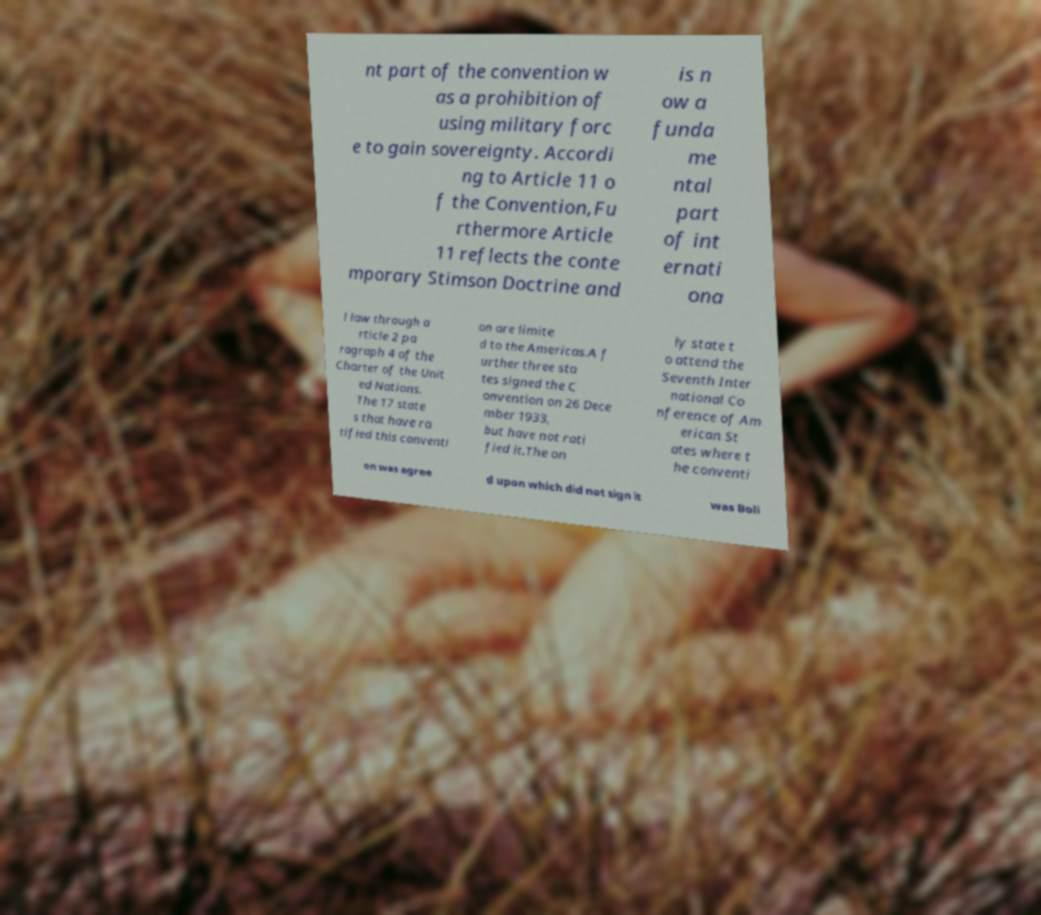What messages or text are displayed in this image? I need them in a readable, typed format. nt part of the convention w as a prohibition of using military forc e to gain sovereignty. Accordi ng to Article 11 o f the Convention,Fu rthermore Article 11 reflects the conte mporary Stimson Doctrine and is n ow a funda me ntal part of int ernati ona l law through a rticle 2 pa ragraph 4 of the Charter of the Unit ed Nations. The 17 state s that have ra tified this conventi on are limite d to the Americas.A f urther three sta tes signed the C onvention on 26 Dece mber 1933, but have not rati fied it.The on ly state t o attend the Seventh Inter national Co nference of Am erican St ates where t he conventi on was agree d upon which did not sign it was Boli 